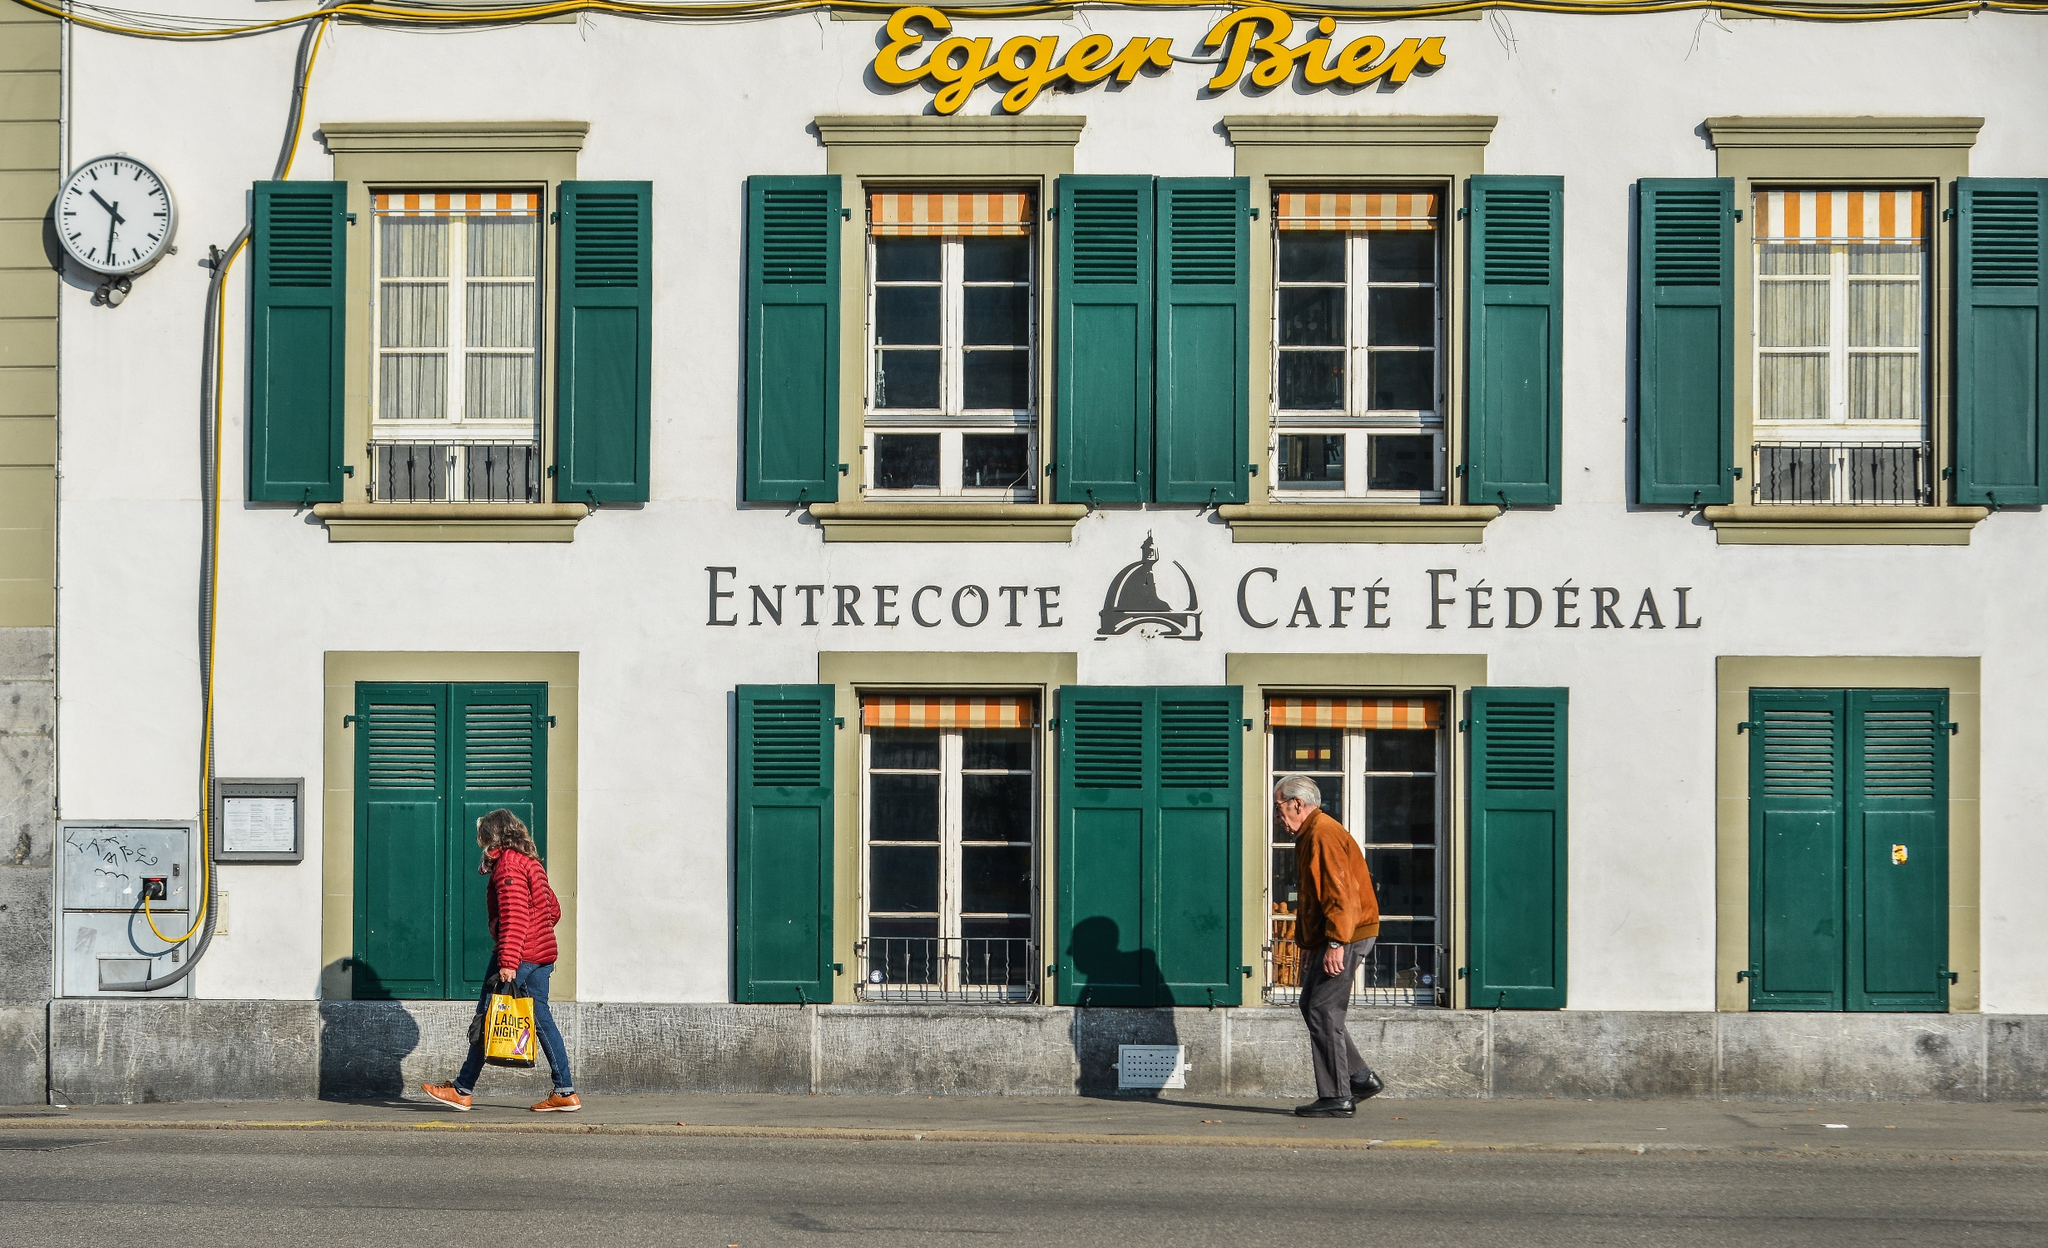If this café could speak, what stories might it tell? If 'Entrecote Café Fédéral' could speak, it would tell stories of the countless memories forged within its walls. It would recount the laughter shared between friends over a cup of coffee, the quiet contemplations of solitary visitors, and the excited chatter of tourists discovering Swiss culture. It would narrate tales of romance blossoming at corner tables, of business deals sealed with a handshake over lunch, and of the elderly gentleman who comes by each day at 10:00 AM sharp for his favorite cup of tea. The café would recall the subtle murmurs of the town's history, the celebrations of local festivals spilling into its street-facing seats, and the comforting routine of the clock ticking away each passing hour. It is a silent observer to the ebb and flow of life's moments, a backdrop to an ever-changing tapestry of human experience. 